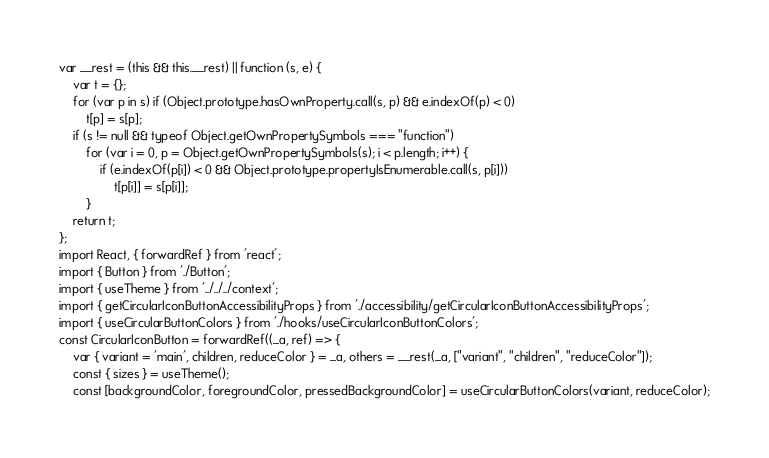Convert code to text. <code><loc_0><loc_0><loc_500><loc_500><_JavaScript_>var __rest = (this && this.__rest) || function (s, e) {
    var t = {};
    for (var p in s) if (Object.prototype.hasOwnProperty.call(s, p) && e.indexOf(p) < 0)
        t[p] = s[p];
    if (s != null && typeof Object.getOwnPropertySymbols === "function")
        for (var i = 0, p = Object.getOwnPropertySymbols(s); i < p.length; i++) {
            if (e.indexOf(p[i]) < 0 && Object.prototype.propertyIsEnumerable.call(s, p[i]))
                t[p[i]] = s[p[i]];
        }
    return t;
};
import React, { forwardRef } from 'react';
import { Button } from './Button';
import { useTheme } from '../../../context';
import { getCircularIconButtonAccessibilityProps } from './accessibility/getCircularIconButtonAccessibilityProps';
import { useCircularButtonColors } from './hooks/useCircularIconButtonColors';
const CircularIconButton = forwardRef((_a, ref) => {
    var { variant = 'main', children, reduceColor } = _a, others = __rest(_a, ["variant", "children", "reduceColor"]);
    const { sizes } = useTheme();
    const [backgroundColor, foregroundColor, pressedBackgroundColor] = useCircularButtonColors(variant, reduceColor);</code> 